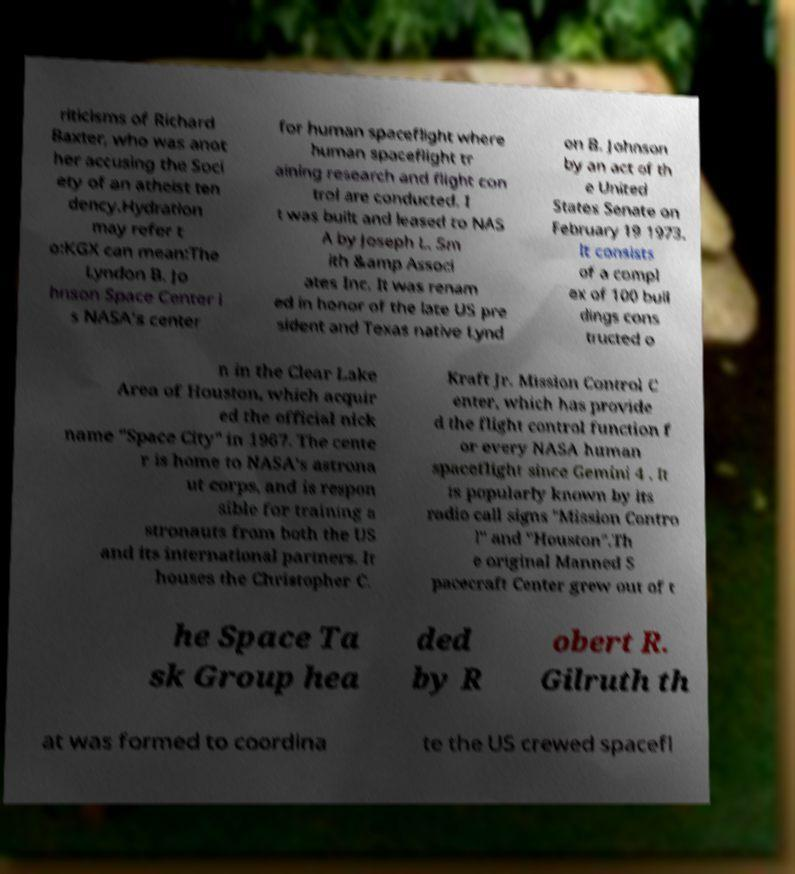Please read and relay the text visible in this image. What does it say? riticisms of Richard Baxter, who was anot her accusing the Soci ety of an atheist ten dency.Hydration may refer t o:KGX can mean:The Lyndon B. Jo hnson Space Center i s NASA's center for human spaceflight where human spaceflight tr aining research and flight con trol are conducted. I t was built and leased to NAS A by Joseph L. Sm ith &amp Associ ates Inc. It was renam ed in honor of the late US pre sident and Texas native Lynd on B. Johnson by an act of th e United States Senate on February 19 1973. It consists of a compl ex of 100 buil dings cons tructed o n in the Clear Lake Area of Houston, which acquir ed the official nick name "Space City" in 1967. The cente r is home to NASA's astrona ut corps, and is respon sible for training a stronauts from both the US and its international partners. It houses the Christopher C. Kraft Jr. Mission Control C enter, which has provide d the flight control function f or every NASA human spaceflight since Gemini 4 . It is popularly known by its radio call signs "Mission Contro l" and "Houston".Th e original Manned S pacecraft Center grew out of t he Space Ta sk Group hea ded by R obert R. Gilruth th at was formed to coordina te the US crewed spacefl 